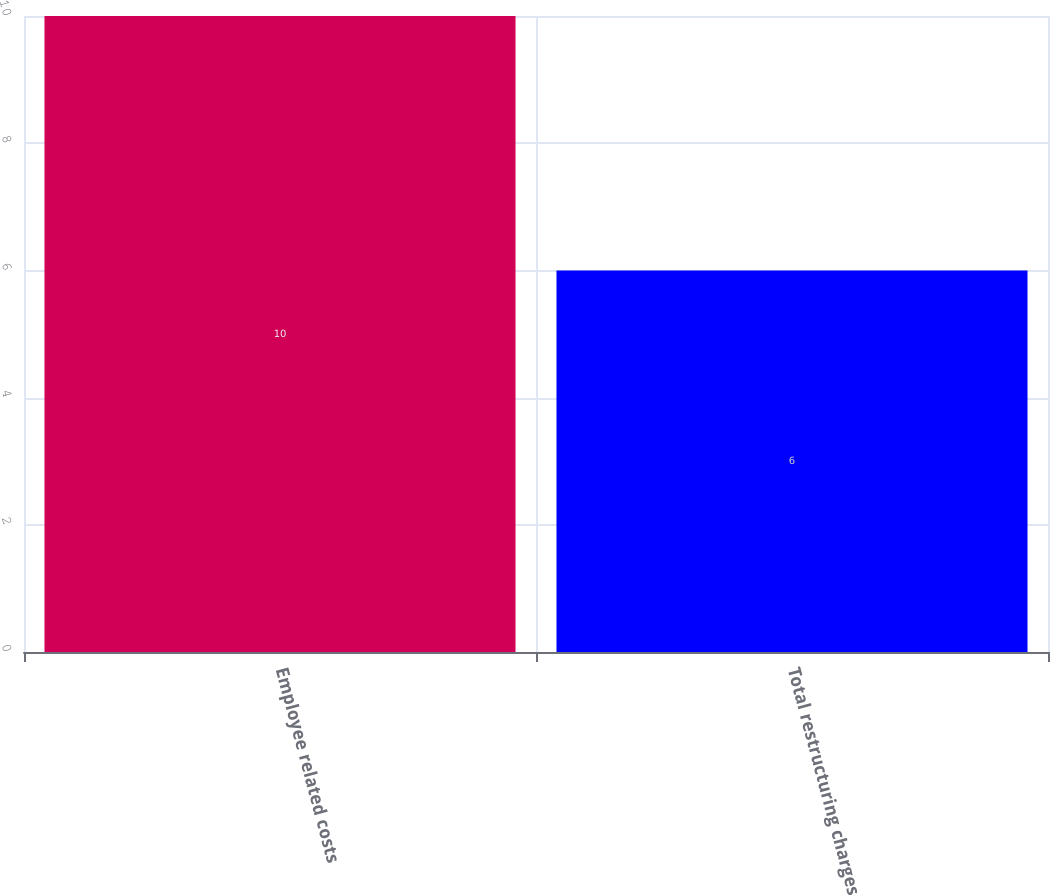Convert chart to OTSL. <chart><loc_0><loc_0><loc_500><loc_500><bar_chart><fcel>Employee related costs<fcel>Total restructuring charges<nl><fcel>10<fcel>6<nl></chart> 